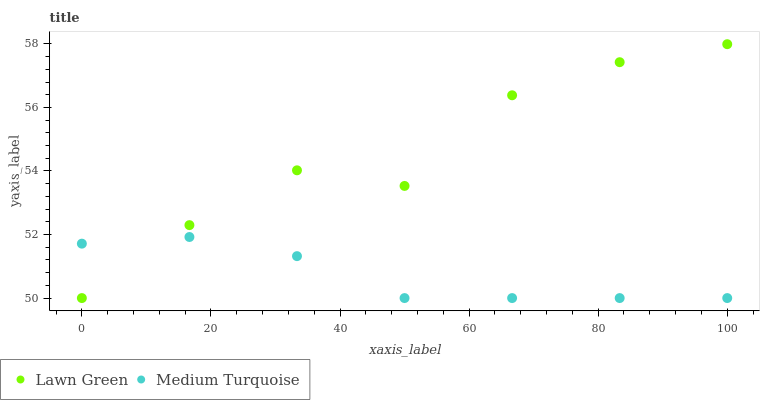Does Medium Turquoise have the minimum area under the curve?
Answer yes or no. Yes. Does Lawn Green have the maximum area under the curve?
Answer yes or no. Yes. Does Medium Turquoise have the maximum area under the curve?
Answer yes or no. No. Is Medium Turquoise the smoothest?
Answer yes or no. Yes. Is Lawn Green the roughest?
Answer yes or no. Yes. Is Medium Turquoise the roughest?
Answer yes or no. No. Does Lawn Green have the lowest value?
Answer yes or no. Yes. Does Lawn Green have the highest value?
Answer yes or no. Yes. Does Medium Turquoise have the highest value?
Answer yes or no. No. Does Lawn Green intersect Medium Turquoise?
Answer yes or no. Yes. Is Lawn Green less than Medium Turquoise?
Answer yes or no. No. Is Lawn Green greater than Medium Turquoise?
Answer yes or no. No. 